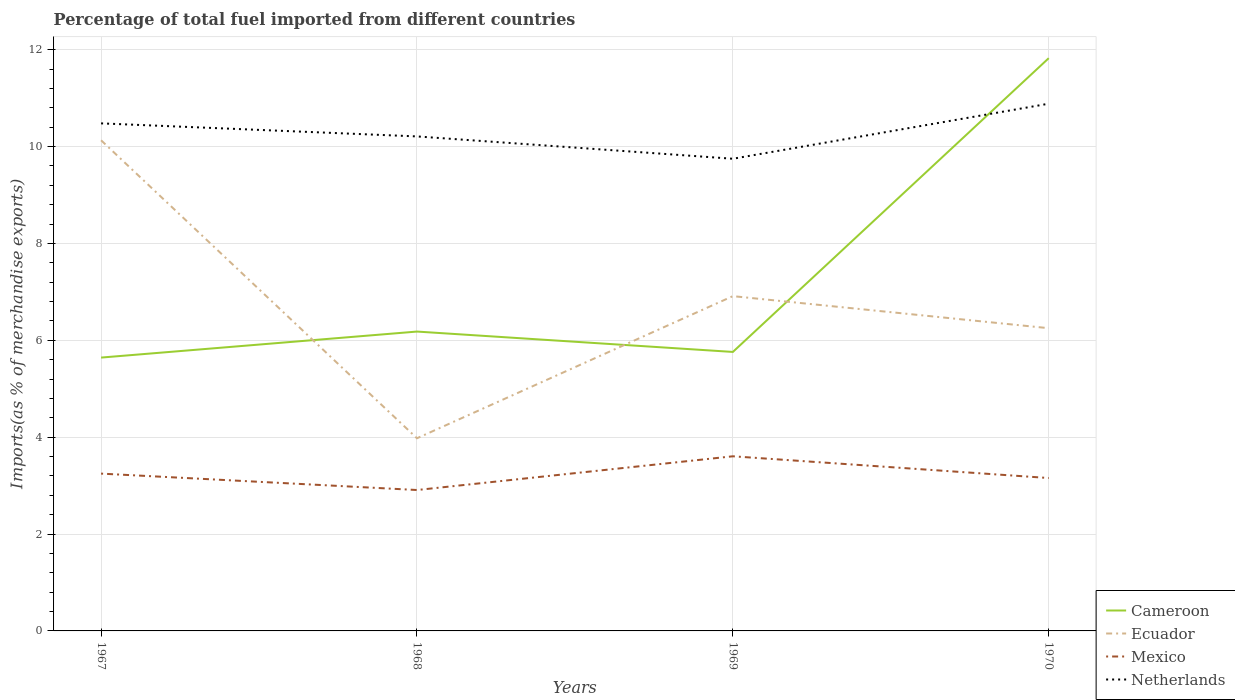How many different coloured lines are there?
Give a very brief answer. 4. Across all years, what is the maximum percentage of imports to different countries in Ecuador?
Provide a short and direct response. 3.98. In which year was the percentage of imports to different countries in Ecuador maximum?
Your answer should be very brief. 1968. What is the total percentage of imports to different countries in Ecuador in the graph?
Your response must be concise. -2.27. What is the difference between the highest and the second highest percentage of imports to different countries in Netherlands?
Give a very brief answer. 1.14. What is the difference between the highest and the lowest percentage of imports to different countries in Cameroon?
Give a very brief answer. 1. Is the percentage of imports to different countries in Mexico strictly greater than the percentage of imports to different countries in Ecuador over the years?
Provide a succinct answer. Yes. Are the values on the major ticks of Y-axis written in scientific E-notation?
Offer a terse response. No. How are the legend labels stacked?
Make the answer very short. Vertical. What is the title of the graph?
Provide a short and direct response. Percentage of total fuel imported from different countries. What is the label or title of the Y-axis?
Your response must be concise. Imports(as % of merchandise exports). What is the Imports(as % of merchandise exports) in Cameroon in 1967?
Your answer should be compact. 5.64. What is the Imports(as % of merchandise exports) of Ecuador in 1967?
Provide a succinct answer. 10.13. What is the Imports(as % of merchandise exports) in Mexico in 1967?
Keep it short and to the point. 3.25. What is the Imports(as % of merchandise exports) in Netherlands in 1967?
Ensure brevity in your answer.  10.48. What is the Imports(as % of merchandise exports) in Cameroon in 1968?
Make the answer very short. 6.18. What is the Imports(as % of merchandise exports) in Ecuador in 1968?
Ensure brevity in your answer.  3.98. What is the Imports(as % of merchandise exports) in Mexico in 1968?
Your response must be concise. 2.91. What is the Imports(as % of merchandise exports) of Netherlands in 1968?
Provide a short and direct response. 10.21. What is the Imports(as % of merchandise exports) in Cameroon in 1969?
Offer a very short reply. 5.76. What is the Imports(as % of merchandise exports) of Ecuador in 1969?
Your answer should be very brief. 6.91. What is the Imports(as % of merchandise exports) of Mexico in 1969?
Provide a short and direct response. 3.61. What is the Imports(as % of merchandise exports) in Netherlands in 1969?
Offer a terse response. 9.75. What is the Imports(as % of merchandise exports) in Cameroon in 1970?
Offer a very short reply. 11.83. What is the Imports(as % of merchandise exports) of Ecuador in 1970?
Give a very brief answer. 6.25. What is the Imports(as % of merchandise exports) of Mexico in 1970?
Your response must be concise. 3.16. What is the Imports(as % of merchandise exports) of Netherlands in 1970?
Provide a succinct answer. 10.88. Across all years, what is the maximum Imports(as % of merchandise exports) in Cameroon?
Provide a short and direct response. 11.83. Across all years, what is the maximum Imports(as % of merchandise exports) of Ecuador?
Give a very brief answer. 10.13. Across all years, what is the maximum Imports(as % of merchandise exports) in Mexico?
Your answer should be compact. 3.61. Across all years, what is the maximum Imports(as % of merchandise exports) of Netherlands?
Offer a terse response. 10.88. Across all years, what is the minimum Imports(as % of merchandise exports) in Cameroon?
Provide a short and direct response. 5.64. Across all years, what is the minimum Imports(as % of merchandise exports) of Ecuador?
Give a very brief answer. 3.98. Across all years, what is the minimum Imports(as % of merchandise exports) of Mexico?
Offer a terse response. 2.91. Across all years, what is the minimum Imports(as % of merchandise exports) of Netherlands?
Offer a terse response. 9.75. What is the total Imports(as % of merchandise exports) of Cameroon in the graph?
Offer a terse response. 29.41. What is the total Imports(as % of merchandise exports) of Ecuador in the graph?
Give a very brief answer. 27.27. What is the total Imports(as % of merchandise exports) in Mexico in the graph?
Your response must be concise. 12.92. What is the total Imports(as % of merchandise exports) in Netherlands in the graph?
Keep it short and to the point. 41.32. What is the difference between the Imports(as % of merchandise exports) of Cameroon in 1967 and that in 1968?
Make the answer very short. -0.54. What is the difference between the Imports(as % of merchandise exports) in Ecuador in 1967 and that in 1968?
Give a very brief answer. 6.15. What is the difference between the Imports(as % of merchandise exports) of Mexico in 1967 and that in 1968?
Ensure brevity in your answer.  0.34. What is the difference between the Imports(as % of merchandise exports) in Netherlands in 1967 and that in 1968?
Provide a short and direct response. 0.27. What is the difference between the Imports(as % of merchandise exports) in Cameroon in 1967 and that in 1969?
Keep it short and to the point. -0.12. What is the difference between the Imports(as % of merchandise exports) of Ecuador in 1967 and that in 1969?
Keep it short and to the point. 3.22. What is the difference between the Imports(as % of merchandise exports) in Mexico in 1967 and that in 1969?
Your answer should be very brief. -0.36. What is the difference between the Imports(as % of merchandise exports) in Netherlands in 1967 and that in 1969?
Ensure brevity in your answer.  0.73. What is the difference between the Imports(as % of merchandise exports) of Cameroon in 1967 and that in 1970?
Keep it short and to the point. -6.18. What is the difference between the Imports(as % of merchandise exports) of Ecuador in 1967 and that in 1970?
Make the answer very short. 3.88. What is the difference between the Imports(as % of merchandise exports) of Mexico in 1967 and that in 1970?
Provide a succinct answer. 0.09. What is the difference between the Imports(as % of merchandise exports) in Netherlands in 1967 and that in 1970?
Provide a succinct answer. -0.41. What is the difference between the Imports(as % of merchandise exports) of Cameroon in 1968 and that in 1969?
Keep it short and to the point. 0.42. What is the difference between the Imports(as % of merchandise exports) of Ecuador in 1968 and that in 1969?
Offer a very short reply. -2.93. What is the difference between the Imports(as % of merchandise exports) in Mexico in 1968 and that in 1969?
Provide a short and direct response. -0.7. What is the difference between the Imports(as % of merchandise exports) of Netherlands in 1968 and that in 1969?
Give a very brief answer. 0.46. What is the difference between the Imports(as % of merchandise exports) in Cameroon in 1968 and that in 1970?
Make the answer very short. -5.64. What is the difference between the Imports(as % of merchandise exports) of Ecuador in 1968 and that in 1970?
Provide a short and direct response. -2.27. What is the difference between the Imports(as % of merchandise exports) in Mexico in 1968 and that in 1970?
Provide a short and direct response. -0.25. What is the difference between the Imports(as % of merchandise exports) of Netherlands in 1968 and that in 1970?
Provide a short and direct response. -0.68. What is the difference between the Imports(as % of merchandise exports) in Cameroon in 1969 and that in 1970?
Make the answer very short. -6.07. What is the difference between the Imports(as % of merchandise exports) in Ecuador in 1969 and that in 1970?
Your answer should be compact. 0.66. What is the difference between the Imports(as % of merchandise exports) in Mexico in 1969 and that in 1970?
Make the answer very short. 0.45. What is the difference between the Imports(as % of merchandise exports) of Netherlands in 1969 and that in 1970?
Your response must be concise. -1.14. What is the difference between the Imports(as % of merchandise exports) of Cameroon in 1967 and the Imports(as % of merchandise exports) of Ecuador in 1968?
Provide a short and direct response. 1.67. What is the difference between the Imports(as % of merchandise exports) in Cameroon in 1967 and the Imports(as % of merchandise exports) in Mexico in 1968?
Ensure brevity in your answer.  2.73. What is the difference between the Imports(as % of merchandise exports) in Cameroon in 1967 and the Imports(as % of merchandise exports) in Netherlands in 1968?
Keep it short and to the point. -4.57. What is the difference between the Imports(as % of merchandise exports) in Ecuador in 1967 and the Imports(as % of merchandise exports) in Mexico in 1968?
Keep it short and to the point. 7.22. What is the difference between the Imports(as % of merchandise exports) in Ecuador in 1967 and the Imports(as % of merchandise exports) in Netherlands in 1968?
Your answer should be very brief. -0.08. What is the difference between the Imports(as % of merchandise exports) in Mexico in 1967 and the Imports(as % of merchandise exports) in Netherlands in 1968?
Provide a succinct answer. -6.96. What is the difference between the Imports(as % of merchandise exports) of Cameroon in 1967 and the Imports(as % of merchandise exports) of Ecuador in 1969?
Offer a terse response. -1.27. What is the difference between the Imports(as % of merchandise exports) of Cameroon in 1967 and the Imports(as % of merchandise exports) of Mexico in 1969?
Give a very brief answer. 2.04. What is the difference between the Imports(as % of merchandise exports) of Cameroon in 1967 and the Imports(as % of merchandise exports) of Netherlands in 1969?
Your response must be concise. -4.11. What is the difference between the Imports(as % of merchandise exports) of Ecuador in 1967 and the Imports(as % of merchandise exports) of Mexico in 1969?
Offer a very short reply. 6.52. What is the difference between the Imports(as % of merchandise exports) of Ecuador in 1967 and the Imports(as % of merchandise exports) of Netherlands in 1969?
Keep it short and to the point. 0.38. What is the difference between the Imports(as % of merchandise exports) of Mexico in 1967 and the Imports(as % of merchandise exports) of Netherlands in 1969?
Your answer should be compact. -6.5. What is the difference between the Imports(as % of merchandise exports) in Cameroon in 1967 and the Imports(as % of merchandise exports) in Ecuador in 1970?
Provide a short and direct response. -0.61. What is the difference between the Imports(as % of merchandise exports) in Cameroon in 1967 and the Imports(as % of merchandise exports) in Mexico in 1970?
Offer a terse response. 2.49. What is the difference between the Imports(as % of merchandise exports) of Cameroon in 1967 and the Imports(as % of merchandise exports) of Netherlands in 1970?
Offer a terse response. -5.24. What is the difference between the Imports(as % of merchandise exports) in Ecuador in 1967 and the Imports(as % of merchandise exports) in Mexico in 1970?
Give a very brief answer. 6.97. What is the difference between the Imports(as % of merchandise exports) of Ecuador in 1967 and the Imports(as % of merchandise exports) of Netherlands in 1970?
Provide a succinct answer. -0.76. What is the difference between the Imports(as % of merchandise exports) of Mexico in 1967 and the Imports(as % of merchandise exports) of Netherlands in 1970?
Your response must be concise. -7.64. What is the difference between the Imports(as % of merchandise exports) of Cameroon in 1968 and the Imports(as % of merchandise exports) of Ecuador in 1969?
Make the answer very short. -0.73. What is the difference between the Imports(as % of merchandise exports) of Cameroon in 1968 and the Imports(as % of merchandise exports) of Mexico in 1969?
Your response must be concise. 2.58. What is the difference between the Imports(as % of merchandise exports) in Cameroon in 1968 and the Imports(as % of merchandise exports) in Netherlands in 1969?
Your response must be concise. -3.57. What is the difference between the Imports(as % of merchandise exports) of Ecuador in 1968 and the Imports(as % of merchandise exports) of Mexico in 1969?
Keep it short and to the point. 0.37. What is the difference between the Imports(as % of merchandise exports) in Ecuador in 1968 and the Imports(as % of merchandise exports) in Netherlands in 1969?
Offer a very short reply. -5.77. What is the difference between the Imports(as % of merchandise exports) in Mexico in 1968 and the Imports(as % of merchandise exports) in Netherlands in 1969?
Give a very brief answer. -6.84. What is the difference between the Imports(as % of merchandise exports) of Cameroon in 1968 and the Imports(as % of merchandise exports) of Ecuador in 1970?
Provide a succinct answer. -0.07. What is the difference between the Imports(as % of merchandise exports) in Cameroon in 1968 and the Imports(as % of merchandise exports) in Mexico in 1970?
Offer a terse response. 3.02. What is the difference between the Imports(as % of merchandise exports) in Cameroon in 1968 and the Imports(as % of merchandise exports) in Netherlands in 1970?
Your answer should be compact. -4.7. What is the difference between the Imports(as % of merchandise exports) in Ecuador in 1968 and the Imports(as % of merchandise exports) in Mexico in 1970?
Offer a very short reply. 0.82. What is the difference between the Imports(as % of merchandise exports) in Ecuador in 1968 and the Imports(as % of merchandise exports) in Netherlands in 1970?
Your response must be concise. -6.91. What is the difference between the Imports(as % of merchandise exports) in Mexico in 1968 and the Imports(as % of merchandise exports) in Netherlands in 1970?
Your answer should be compact. -7.98. What is the difference between the Imports(as % of merchandise exports) of Cameroon in 1969 and the Imports(as % of merchandise exports) of Ecuador in 1970?
Make the answer very short. -0.49. What is the difference between the Imports(as % of merchandise exports) of Cameroon in 1969 and the Imports(as % of merchandise exports) of Mexico in 1970?
Keep it short and to the point. 2.6. What is the difference between the Imports(as % of merchandise exports) of Cameroon in 1969 and the Imports(as % of merchandise exports) of Netherlands in 1970?
Your answer should be very brief. -5.12. What is the difference between the Imports(as % of merchandise exports) in Ecuador in 1969 and the Imports(as % of merchandise exports) in Mexico in 1970?
Keep it short and to the point. 3.76. What is the difference between the Imports(as % of merchandise exports) in Ecuador in 1969 and the Imports(as % of merchandise exports) in Netherlands in 1970?
Offer a very short reply. -3.97. What is the difference between the Imports(as % of merchandise exports) in Mexico in 1969 and the Imports(as % of merchandise exports) in Netherlands in 1970?
Provide a succinct answer. -7.28. What is the average Imports(as % of merchandise exports) in Cameroon per year?
Your answer should be compact. 7.35. What is the average Imports(as % of merchandise exports) of Ecuador per year?
Offer a very short reply. 6.82. What is the average Imports(as % of merchandise exports) of Mexico per year?
Your response must be concise. 3.23. What is the average Imports(as % of merchandise exports) in Netherlands per year?
Offer a very short reply. 10.33. In the year 1967, what is the difference between the Imports(as % of merchandise exports) in Cameroon and Imports(as % of merchandise exports) in Ecuador?
Give a very brief answer. -4.49. In the year 1967, what is the difference between the Imports(as % of merchandise exports) of Cameroon and Imports(as % of merchandise exports) of Mexico?
Provide a short and direct response. 2.4. In the year 1967, what is the difference between the Imports(as % of merchandise exports) in Cameroon and Imports(as % of merchandise exports) in Netherlands?
Provide a short and direct response. -4.84. In the year 1967, what is the difference between the Imports(as % of merchandise exports) in Ecuador and Imports(as % of merchandise exports) in Mexico?
Your answer should be compact. 6.88. In the year 1967, what is the difference between the Imports(as % of merchandise exports) in Ecuador and Imports(as % of merchandise exports) in Netherlands?
Offer a terse response. -0.35. In the year 1967, what is the difference between the Imports(as % of merchandise exports) in Mexico and Imports(as % of merchandise exports) in Netherlands?
Give a very brief answer. -7.23. In the year 1968, what is the difference between the Imports(as % of merchandise exports) in Cameroon and Imports(as % of merchandise exports) in Ecuador?
Keep it short and to the point. 2.2. In the year 1968, what is the difference between the Imports(as % of merchandise exports) of Cameroon and Imports(as % of merchandise exports) of Mexico?
Your answer should be compact. 3.27. In the year 1968, what is the difference between the Imports(as % of merchandise exports) in Cameroon and Imports(as % of merchandise exports) in Netherlands?
Offer a terse response. -4.03. In the year 1968, what is the difference between the Imports(as % of merchandise exports) in Ecuador and Imports(as % of merchandise exports) in Mexico?
Offer a terse response. 1.07. In the year 1968, what is the difference between the Imports(as % of merchandise exports) of Ecuador and Imports(as % of merchandise exports) of Netherlands?
Offer a terse response. -6.23. In the year 1968, what is the difference between the Imports(as % of merchandise exports) of Mexico and Imports(as % of merchandise exports) of Netherlands?
Offer a terse response. -7.3. In the year 1969, what is the difference between the Imports(as % of merchandise exports) of Cameroon and Imports(as % of merchandise exports) of Ecuador?
Offer a very short reply. -1.15. In the year 1969, what is the difference between the Imports(as % of merchandise exports) in Cameroon and Imports(as % of merchandise exports) in Mexico?
Give a very brief answer. 2.15. In the year 1969, what is the difference between the Imports(as % of merchandise exports) of Cameroon and Imports(as % of merchandise exports) of Netherlands?
Keep it short and to the point. -3.99. In the year 1969, what is the difference between the Imports(as % of merchandise exports) in Ecuador and Imports(as % of merchandise exports) in Mexico?
Your response must be concise. 3.31. In the year 1969, what is the difference between the Imports(as % of merchandise exports) of Ecuador and Imports(as % of merchandise exports) of Netherlands?
Give a very brief answer. -2.84. In the year 1969, what is the difference between the Imports(as % of merchandise exports) of Mexico and Imports(as % of merchandise exports) of Netherlands?
Offer a terse response. -6.14. In the year 1970, what is the difference between the Imports(as % of merchandise exports) in Cameroon and Imports(as % of merchandise exports) in Ecuador?
Your answer should be very brief. 5.57. In the year 1970, what is the difference between the Imports(as % of merchandise exports) of Cameroon and Imports(as % of merchandise exports) of Mexico?
Your response must be concise. 8.67. In the year 1970, what is the difference between the Imports(as % of merchandise exports) in Cameroon and Imports(as % of merchandise exports) in Netherlands?
Make the answer very short. 0.94. In the year 1970, what is the difference between the Imports(as % of merchandise exports) of Ecuador and Imports(as % of merchandise exports) of Mexico?
Ensure brevity in your answer.  3.09. In the year 1970, what is the difference between the Imports(as % of merchandise exports) of Ecuador and Imports(as % of merchandise exports) of Netherlands?
Ensure brevity in your answer.  -4.63. In the year 1970, what is the difference between the Imports(as % of merchandise exports) of Mexico and Imports(as % of merchandise exports) of Netherlands?
Your response must be concise. -7.73. What is the ratio of the Imports(as % of merchandise exports) in Cameroon in 1967 to that in 1968?
Offer a terse response. 0.91. What is the ratio of the Imports(as % of merchandise exports) in Ecuador in 1967 to that in 1968?
Your answer should be very brief. 2.55. What is the ratio of the Imports(as % of merchandise exports) in Mexico in 1967 to that in 1968?
Provide a succinct answer. 1.12. What is the ratio of the Imports(as % of merchandise exports) of Netherlands in 1967 to that in 1968?
Give a very brief answer. 1.03. What is the ratio of the Imports(as % of merchandise exports) of Cameroon in 1967 to that in 1969?
Offer a terse response. 0.98. What is the ratio of the Imports(as % of merchandise exports) of Ecuador in 1967 to that in 1969?
Provide a succinct answer. 1.47. What is the ratio of the Imports(as % of merchandise exports) of Mexico in 1967 to that in 1969?
Give a very brief answer. 0.9. What is the ratio of the Imports(as % of merchandise exports) in Netherlands in 1967 to that in 1969?
Give a very brief answer. 1.07. What is the ratio of the Imports(as % of merchandise exports) of Cameroon in 1967 to that in 1970?
Give a very brief answer. 0.48. What is the ratio of the Imports(as % of merchandise exports) in Ecuador in 1967 to that in 1970?
Your answer should be compact. 1.62. What is the ratio of the Imports(as % of merchandise exports) in Mexico in 1967 to that in 1970?
Ensure brevity in your answer.  1.03. What is the ratio of the Imports(as % of merchandise exports) in Netherlands in 1967 to that in 1970?
Your answer should be very brief. 0.96. What is the ratio of the Imports(as % of merchandise exports) of Cameroon in 1968 to that in 1969?
Offer a terse response. 1.07. What is the ratio of the Imports(as % of merchandise exports) of Ecuador in 1968 to that in 1969?
Ensure brevity in your answer.  0.58. What is the ratio of the Imports(as % of merchandise exports) in Mexico in 1968 to that in 1969?
Offer a terse response. 0.81. What is the ratio of the Imports(as % of merchandise exports) of Netherlands in 1968 to that in 1969?
Provide a short and direct response. 1.05. What is the ratio of the Imports(as % of merchandise exports) in Cameroon in 1968 to that in 1970?
Give a very brief answer. 0.52. What is the ratio of the Imports(as % of merchandise exports) of Ecuador in 1968 to that in 1970?
Give a very brief answer. 0.64. What is the ratio of the Imports(as % of merchandise exports) in Mexico in 1968 to that in 1970?
Your answer should be very brief. 0.92. What is the ratio of the Imports(as % of merchandise exports) of Netherlands in 1968 to that in 1970?
Provide a short and direct response. 0.94. What is the ratio of the Imports(as % of merchandise exports) in Cameroon in 1969 to that in 1970?
Offer a terse response. 0.49. What is the ratio of the Imports(as % of merchandise exports) of Ecuador in 1969 to that in 1970?
Your answer should be very brief. 1.11. What is the ratio of the Imports(as % of merchandise exports) of Mexico in 1969 to that in 1970?
Keep it short and to the point. 1.14. What is the ratio of the Imports(as % of merchandise exports) of Netherlands in 1969 to that in 1970?
Offer a very short reply. 0.9. What is the difference between the highest and the second highest Imports(as % of merchandise exports) in Cameroon?
Ensure brevity in your answer.  5.64. What is the difference between the highest and the second highest Imports(as % of merchandise exports) of Ecuador?
Ensure brevity in your answer.  3.22. What is the difference between the highest and the second highest Imports(as % of merchandise exports) of Mexico?
Make the answer very short. 0.36. What is the difference between the highest and the second highest Imports(as % of merchandise exports) in Netherlands?
Your answer should be very brief. 0.41. What is the difference between the highest and the lowest Imports(as % of merchandise exports) of Cameroon?
Keep it short and to the point. 6.18. What is the difference between the highest and the lowest Imports(as % of merchandise exports) in Ecuador?
Provide a succinct answer. 6.15. What is the difference between the highest and the lowest Imports(as % of merchandise exports) of Mexico?
Your answer should be very brief. 0.7. What is the difference between the highest and the lowest Imports(as % of merchandise exports) in Netherlands?
Give a very brief answer. 1.14. 